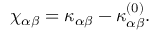<formula> <loc_0><loc_0><loc_500><loc_500>\begin{array} { r } { { \chi } _ { \alpha \beta } = { \kappa } _ { \alpha \beta } - { \kappa } _ { \alpha \beta } ^ { ( 0 ) } . } \end{array}</formula> 